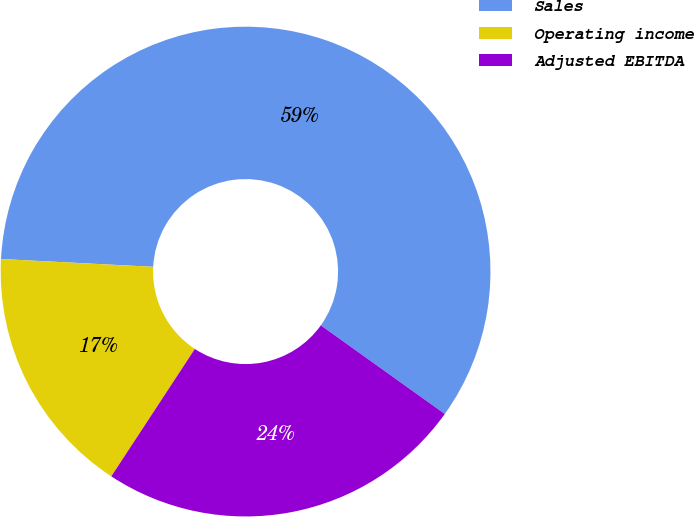Convert chart. <chart><loc_0><loc_0><loc_500><loc_500><pie_chart><fcel>Sales<fcel>Operating income<fcel>Adjusted EBITDA<nl><fcel>59.06%<fcel>16.58%<fcel>24.36%<nl></chart> 